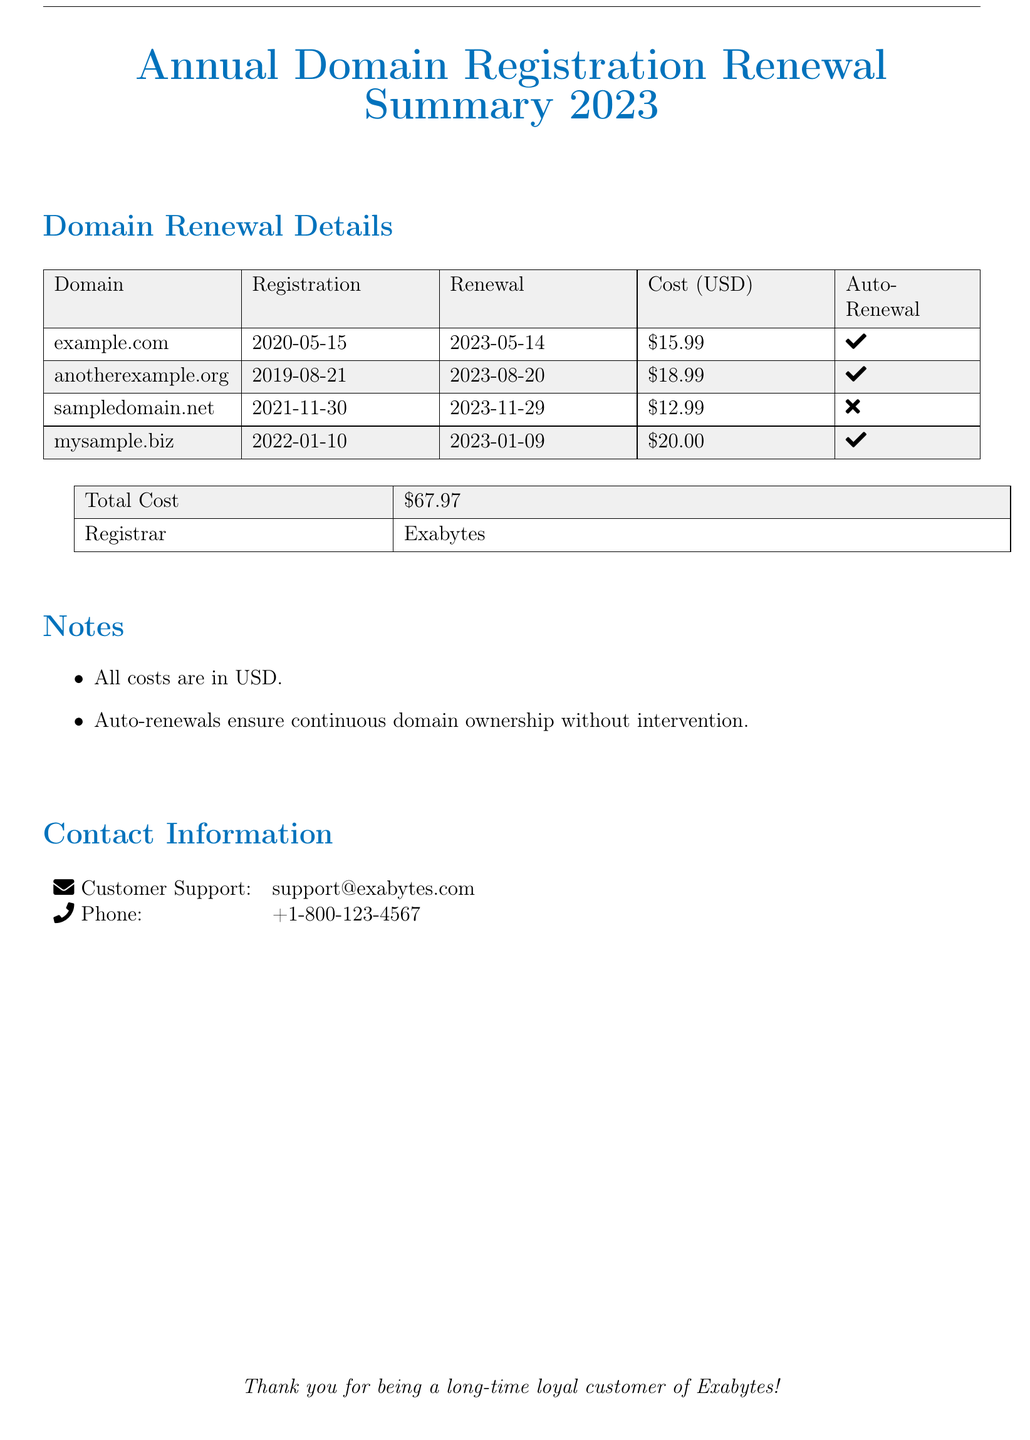What is the total cost of domain renewals? The total cost is specified in the document as the sum of all individual domain renewal costs.
Answer: $67.97 How many domains are listed for renewal? The number of domains is determined by counting the entries in the domain renewal details table.
Answer: 4 When is the renewal date for example.com? The renewal date can be found next to the domain name in the table under the "Renewal" column.
Answer: 2023-05-14 Which domain does not have auto-renewal? This information is presented in the "Auto-Renewal" column, which indicates whether each domain has the feature.
Answer: sampledomain.net What is the registration date for anotherexample.org? The registration date is shown in the document next to the domain name under the "Registration" column.
Answer: 2019-08-21 Who is the registrar for these domains? The registrar's name is specifically stated in the summary table.
Answer: Exabytes What is the cost of renewing mysample.biz? The renewal cost is listed under the "Cost (USD)" column for that specific domain.
Answer: $20.00 Is continuous domain ownership ensured for all domains? This can be inferred from the "Auto-Renewal" column indicating which domains have the feature.
Answer: No 